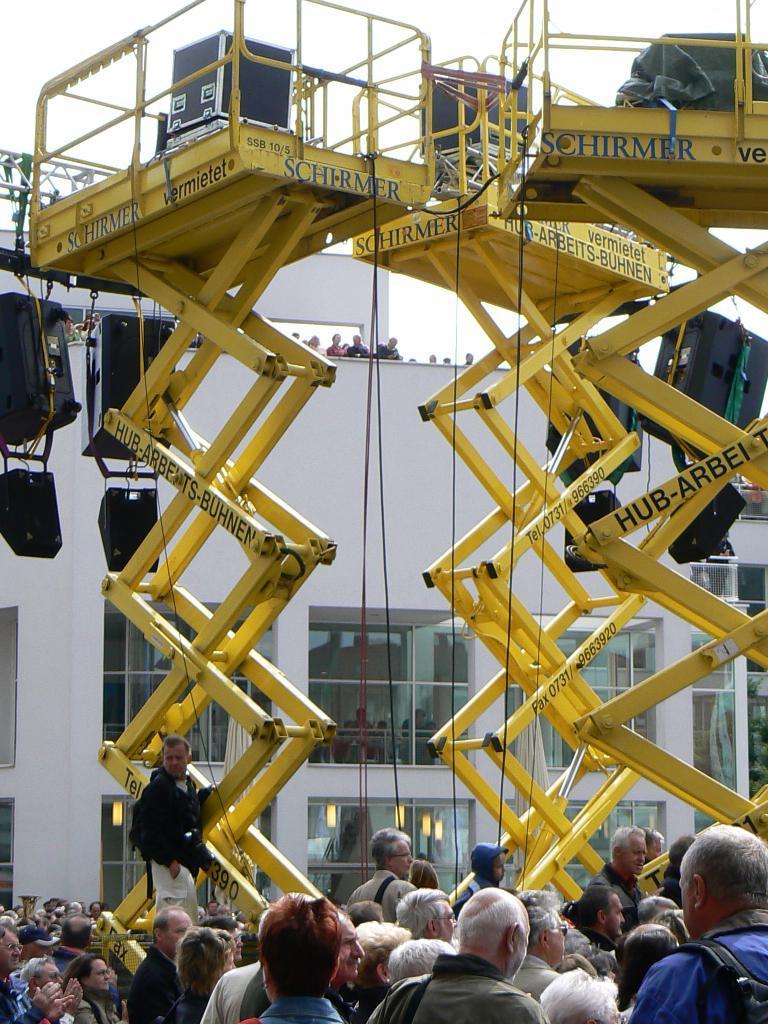Could you give a brief overview of what you see in this image? In this picture we can see three lifting machines, there are some people standing at the bottom, in the background there is a building, we can see glasses of the building, there is the sky at the top of the picture. 